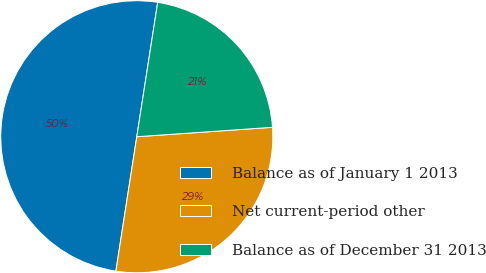Convert chart to OTSL. <chart><loc_0><loc_0><loc_500><loc_500><pie_chart><fcel>Balance as of January 1 2013<fcel>Net current-period other<fcel>Balance as of December 31 2013<nl><fcel>50.0%<fcel>28.56%<fcel>21.44%<nl></chart> 